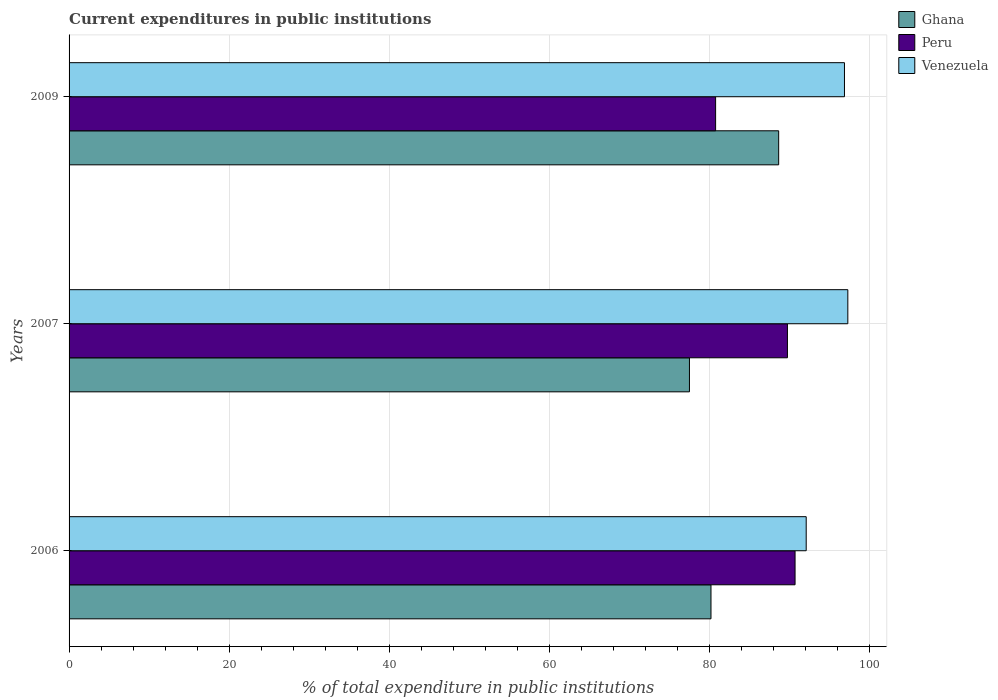Are the number of bars on each tick of the Y-axis equal?
Ensure brevity in your answer.  Yes. In how many cases, is the number of bars for a given year not equal to the number of legend labels?
Offer a very short reply. 0. What is the current expenditures in public institutions in Ghana in 2007?
Make the answer very short. 77.54. Across all years, what is the maximum current expenditures in public institutions in Ghana?
Offer a terse response. 88.7. Across all years, what is the minimum current expenditures in public institutions in Ghana?
Offer a very short reply. 77.54. In which year was the current expenditures in public institutions in Venezuela maximum?
Your response must be concise. 2007. What is the total current expenditures in public institutions in Ghana in the graph?
Keep it short and to the point. 246.47. What is the difference between the current expenditures in public institutions in Peru in 2006 and that in 2007?
Keep it short and to the point. 0.95. What is the difference between the current expenditures in public institutions in Peru in 2006 and the current expenditures in public institutions in Venezuela in 2009?
Your response must be concise. -6.17. What is the average current expenditures in public institutions in Venezuela per year?
Ensure brevity in your answer.  95.47. In the year 2006, what is the difference between the current expenditures in public institutions in Ghana and current expenditures in public institutions in Peru?
Make the answer very short. -10.51. What is the ratio of the current expenditures in public institutions in Ghana in 2006 to that in 2007?
Make the answer very short. 1.03. Is the difference between the current expenditures in public institutions in Ghana in 2006 and 2009 greater than the difference between the current expenditures in public institutions in Peru in 2006 and 2009?
Provide a short and direct response. No. What is the difference between the highest and the second highest current expenditures in public institutions in Peru?
Offer a terse response. 0.95. What is the difference between the highest and the lowest current expenditures in public institutions in Peru?
Your answer should be very brief. 9.93. What does the 1st bar from the top in 2006 represents?
Provide a succinct answer. Venezuela. What does the 2nd bar from the bottom in 2007 represents?
Your response must be concise. Peru. How many bars are there?
Your answer should be compact. 9. Are all the bars in the graph horizontal?
Your answer should be compact. Yes. What is the difference between two consecutive major ticks on the X-axis?
Provide a short and direct response. 20. Does the graph contain any zero values?
Offer a terse response. No. How many legend labels are there?
Offer a terse response. 3. What is the title of the graph?
Make the answer very short. Current expenditures in public institutions. What is the label or title of the X-axis?
Your response must be concise. % of total expenditure in public institutions. What is the % of total expenditure in public institutions of Ghana in 2006?
Offer a terse response. 80.23. What is the % of total expenditure in public institutions of Peru in 2006?
Your response must be concise. 90.74. What is the % of total expenditure in public institutions in Venezuela in 2006?
Offer a very short reply. 92.14. What is the % of total expenditure in public institutions of Ghana in 2007?
Provide a short and direct response. 77.54. What is the % of total expenditure in public institutions in Peru in 2007?
Provide a succinct answer. 89.79. What is the % of total expenditure in public institutions in Venezuela in 2007?
Make the answer very short. 97.34. What is the % of total expenditure in public institutions in Ghana in 2009?
Keep it short and to the point. 88.7. What is the % of total expenditure in public institutions in Peru in 2009?
Make the answer very short. 80.81. What is the % of total expenditure in public institutions of Venezuela in 2009?
Keep it short and to the point. 96.92. Across all years, what is the maximum % of total expenditure in public institutions of Ghana?
Your response must be concise. 88.7. Across all years, what is the maximum % of total expenditure in public institutions in Peru?
Offer a terse response. 90.74. Across all years, what is the maximum % of total expenditure in public institutions of Venezuela?
Your answer should be very brief. 97.34. Across all years, what is the minimum % of total expenditure in public institutions of Ghana?
Your answer should be very brief. 77.54. Across all years, what is the minimum % of total expenditure in public institutions in Peru?
Give a very brief answer. 80.81. Across all years, what is the minimum % of total expenditure in public institutions of Venezuela?
Offer a terse response. 92.14. What is the total % of total expenditure in public institutions in Ghana in the graph?
Provide a short and direct response. 246.47. What is the total % of total expenditure in public institutions in Peru in the graph?
Give a very brief answer. 261.35. What is the total % of total expenditure in public institutions in Venezuela in the graph?
Ensure brevity in your answer.  286.4. What is the difference between the % of total expenditure in public institutions of Ghana in 2006 and that in 2007?
Offer a very short reply. 2.69. What is the difference between the % of total expenditure in public institutions of Peru in 2006 and that in 2007?
Make the answer very short. 0.95. What is the difference between the % of total expenditure in public institutions of Venezuela in 2006 and that in 2007?
Provide a succinct answer. -5.2. What is the difference between the % of total expenditure in public institutions of Ghana in 2006 and that in 2009?
Make the answer very short. -8.46. What is the difference between the % of total expenditure in public institutions in Peru in 2006 and that in 2009?
Give a very brief answer. 9.93. What is the difference between the % of total expenditure in public institutions of Venezuela in 2006 and that in 2009?
Give a very brief answer. -4.78. What is the difference between the % of total expenditure in public institutions in Ghana in 2007 and that in 2009?
Offer a very short reply. -11.15. What is the difference between the % of total expenditure in public institutions of Peru in 2007 and that in 2009?
Provide a short and direct response. 8.98. What is the difference between the % of total expenditure in public institutions of Venezuela in 2007 and that in 2009?
Make the answer very short. 0.42. What is the difference between the % of total expenditure in public institutions in Ghana in 2006 and the % of total expenditure in public institutions in Peru in 2007?
Keep it short and to the point. -9.56. What is the difference between the % of total expenditure in public institutions of Ghana in 2006 and the % of total expenditure in public institutions of Venezuela in 2007?
Your answer should be very brief. -17.11. What is the difference between the % of total expenditure in public institutions in Peru in 2006 and the % of total expenditure in public institutions in Venezuela in 2007?
Provide a short and direct response. -6.6. What is the difference between the % of total expenditure in public institutions of Ghana in 2006 and the % of total expenditure in public institutions of Peru in 2009?
Keep it short and to the point. -0.58. What is the difference between the % of total expenditure in public institutions of Ghana in 2006 and the % of total expenditure in public institutions of Venezuela in 2009?
Make the answer very short. -16.68. What is the difference between the % of total expenditure in public institutions in Peru in 2006 and the % of total expenditure in public institutions in Venezuela in 2009?
Offer a terse response. -6.17. What is the difference between the % of total expenditure in public institutions of Ghana in 2007 and the % of total expenditure in public institutions of Peru in 2009?
Your answer should be very brief. -3.27. What is the difference between the % of total expenditure in public institutions in Ghana in 2007 and the % of total expenditure in public institutions in Venezuela in 2009?
Your answer should be compact. -19.37. What is the difference between the % of total expenditure in public institutions in Peru in 2007 and the % of total expenditure in public institutions in Venezuela in 2009?
Ensure brevity in your answer.  -7.13. What is the average % of total expenditure in public institutions of Ghana per year?
Your answer should be compact. 82.16. What is the average % of total expenditure in public institutions in Peru per year?
Offer a very short reply. 87.12. What is the average % of total expenditure in public institutions of Venezuela per year?
Provide a short and direct response. 95.47. In the year 2006, what is the difference between the % of total expenditure in public institutions in Ghana and % of total expenditure in public institutions in Peru?
Give a very brief answer. -10.51. In the year 2006, what is the difference between the % of total expenditure in public institutions in Ghana and % of total expenditure in public institutions in Venezuela?
Ensure brevity in your answer.  -11.9. In the year 2006, what is the difference between the % of total expenditure in public institutions of Peru and % of total expenditure in public institutions of Venezuela?
Offer a terse response. -1.39. In the year 2007, what is the difference between the % of total expenditure in public institutions of Ghana and % of total expenditure in public institutions of Peru?
Your response must be concise. -12.25. In the year 2007, what is the difference between the % of total expenditure in public institutions of Ghana and % of total expenditure in public institutions of Venezuela?
Offer a terse response. -19.8. In the year 2007, what is the difference between the % of total expenditure in public institutions in Peru and % of total expenditure in public institutions in Venezuela?
Offer a terse response. -7.55. In the year 2009, what is the difference between the % of total expenditure in public institutions of Ghana and % of total expenditure in public institutions of Peru?
Keep it short and to the point. 7.88. In the year 2009, what is the difference between the % of total expenditure in public institutions of Ghana and % of total expenditure in public institutions of Venezuela?
Your answer should be very brief. -8.22. In the year 2009, what is the difference between the % of total expenditure in public institutions of Peru and % of total expenditure in public institutions of Venezuela?
Your response must be concise. -16.11. What is the ratio of the % of total expenditure in public institutions of Ghana in 2006 to that in 2007?
Your response must be concise. 1.03. What is the ratio of the % of total expenditure in public institutions in Peru in 2006 to that in 2007?
Make the answer very short. 1.01. What is the ratio of the % of total expenditure in public institutions of Venezuela in 2006 to that in 2007?
Keep it short and to the point. 0.95. What is the ratio of the % of total expenditure in public institutions in Ghana in 2006 to that in 2009?
Give a very brief answer. 0.9. What is the ratio of the % of total expenditure in public institutions in Peru in 2006 to that in 2009?
Your answer should be very brief. 1.12. What is the ratio of the % of total expenditure in public institutions of Venezuela in 2006 to that in 2009?
Provide a short and direct response. 0.95. What is the ratio of the % of total expenditure in public institutions of Ghana in 2007 to that in 2009?
Offer a very short reply. 0.87. What is the difference between the highest and the second highest % of total expenditure in public institutions in Ghana?
Your response must be concise. 8.46. What is the difference between the highest and the second highest % of total expenditure in public institutions in Peru?
Offer a terse response. 0.95. What is the difference between the highest and the second highest % of total expenditure in public institutions of Venezuela?
Your answer should be compact. 0.42. What is the difference between the highest and the lowest % of total expenditure in public institutions of Ghana?
Give a very brief answer. 11.15. What is the difference between the highest and the lowest % of total expenditure in public institutions of Peru?
Provide a short and direct response. 9.93. What is the difference between the highest and the lowest % of total expenditure in public institutions of Venezuela?
Provide a succinct answer. 5.2. 